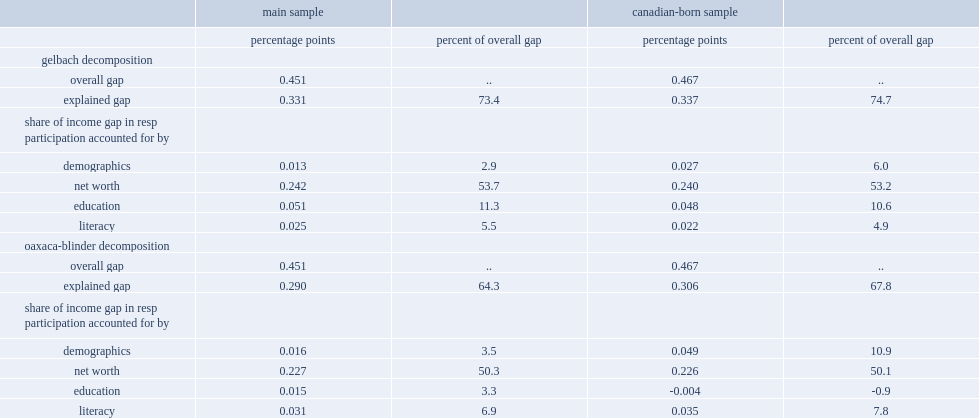What percent of the overall gap in resp participation can explain the differences in literacy? 5.5. 